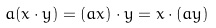Convert formula to latex. <formula><loc_0><loc_0><loc_500><loc_500>a ( x \cdot y ) = ( a x ) \cdot y = x \cdot ( a y )</formula> 